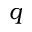<formula> <loc_0><loc_0><loc_500><loc_500>q</formula> 